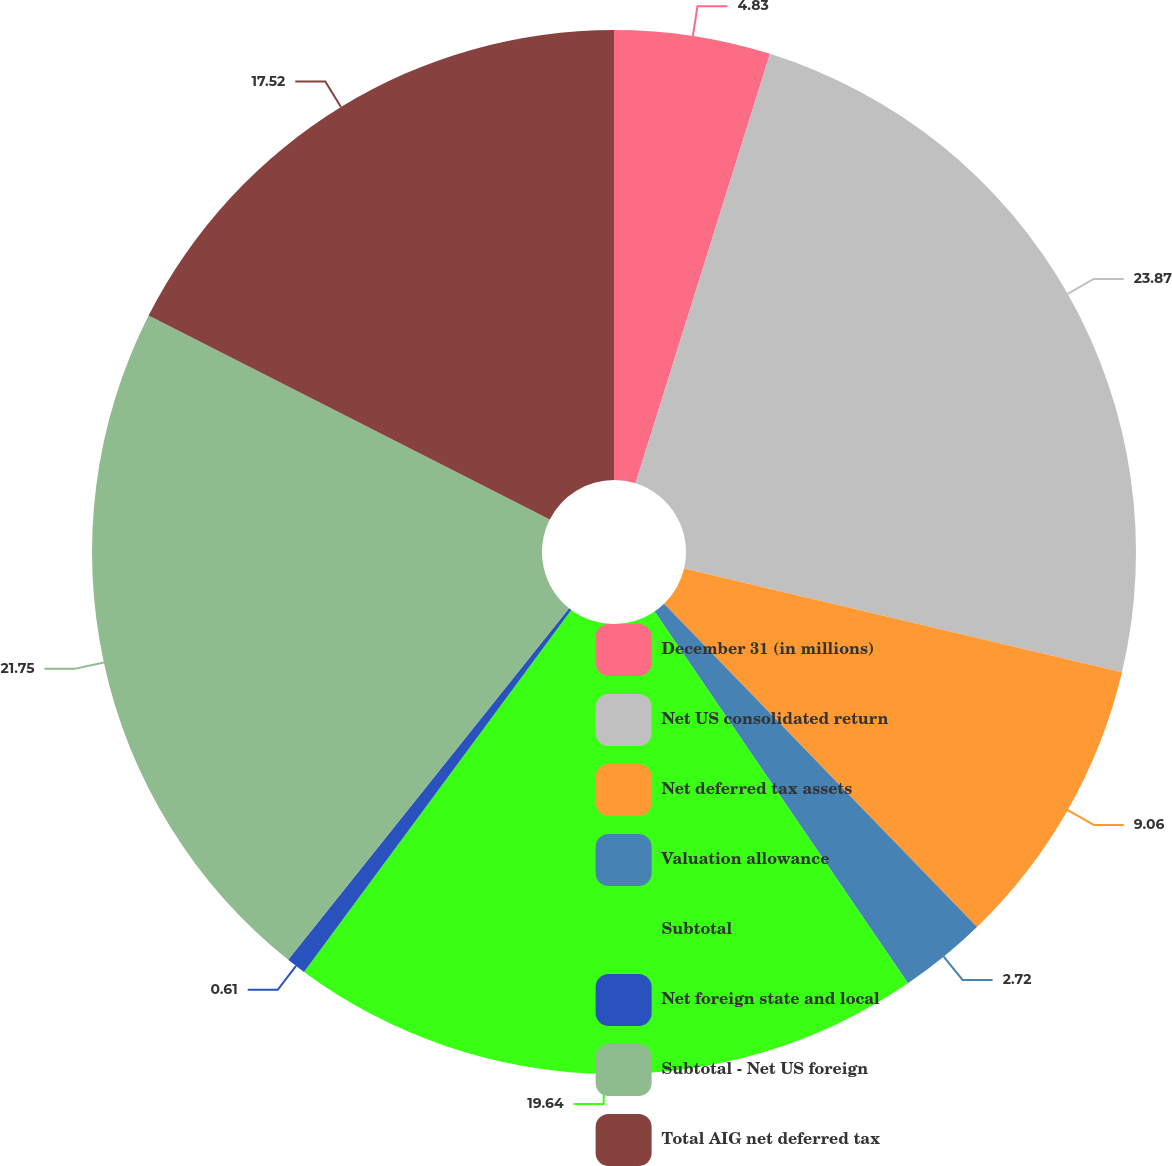Convert chart. <chart><loc_0><loc_0><loc_500><loc_500><pie_chart><fcel>December 31 (in millions)<fcel>Net US consolidated return<fcel>Net deferred tax assets<fcel>Valuation allowance<fcel>Subtotal<fcel>Net foreign state and local<fcel>Subtotal - Net US foreign<fcel>Total AIG net deferred tax<nl><fcel>4.83%<fcel>23.87%<fcel>9.06%<fcel>2.72%<fcel>19.64%<fcel>0.61%<fcel>21.75%<fcel>17.52%<nl></chart> 